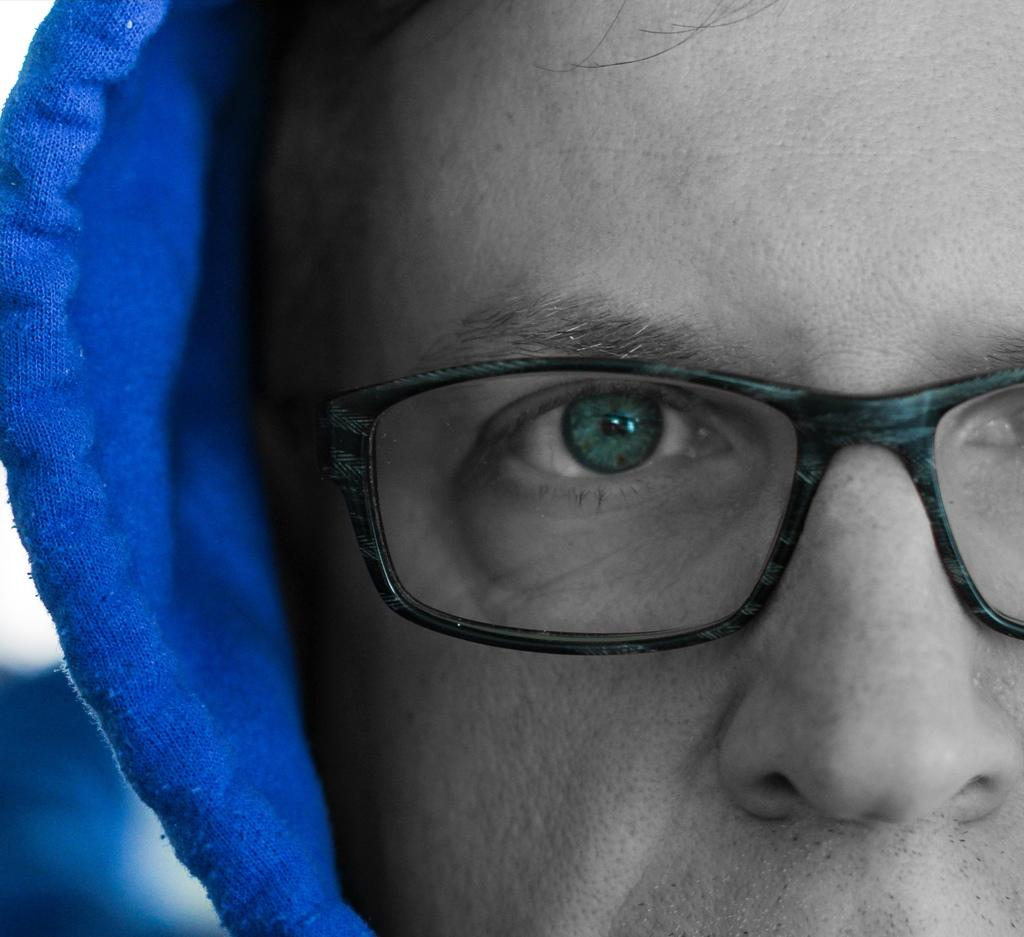What can be observed about the background of the image? The background of the image is blurred. What is the main subject of the image? There is a man's face in the middle of the image. How many flowers are visible in the image? There are no flowers present in the image. What type of receipt can be seen in the man's hand in the image? There is no receipt or any indication of the man holding anything in the image. 